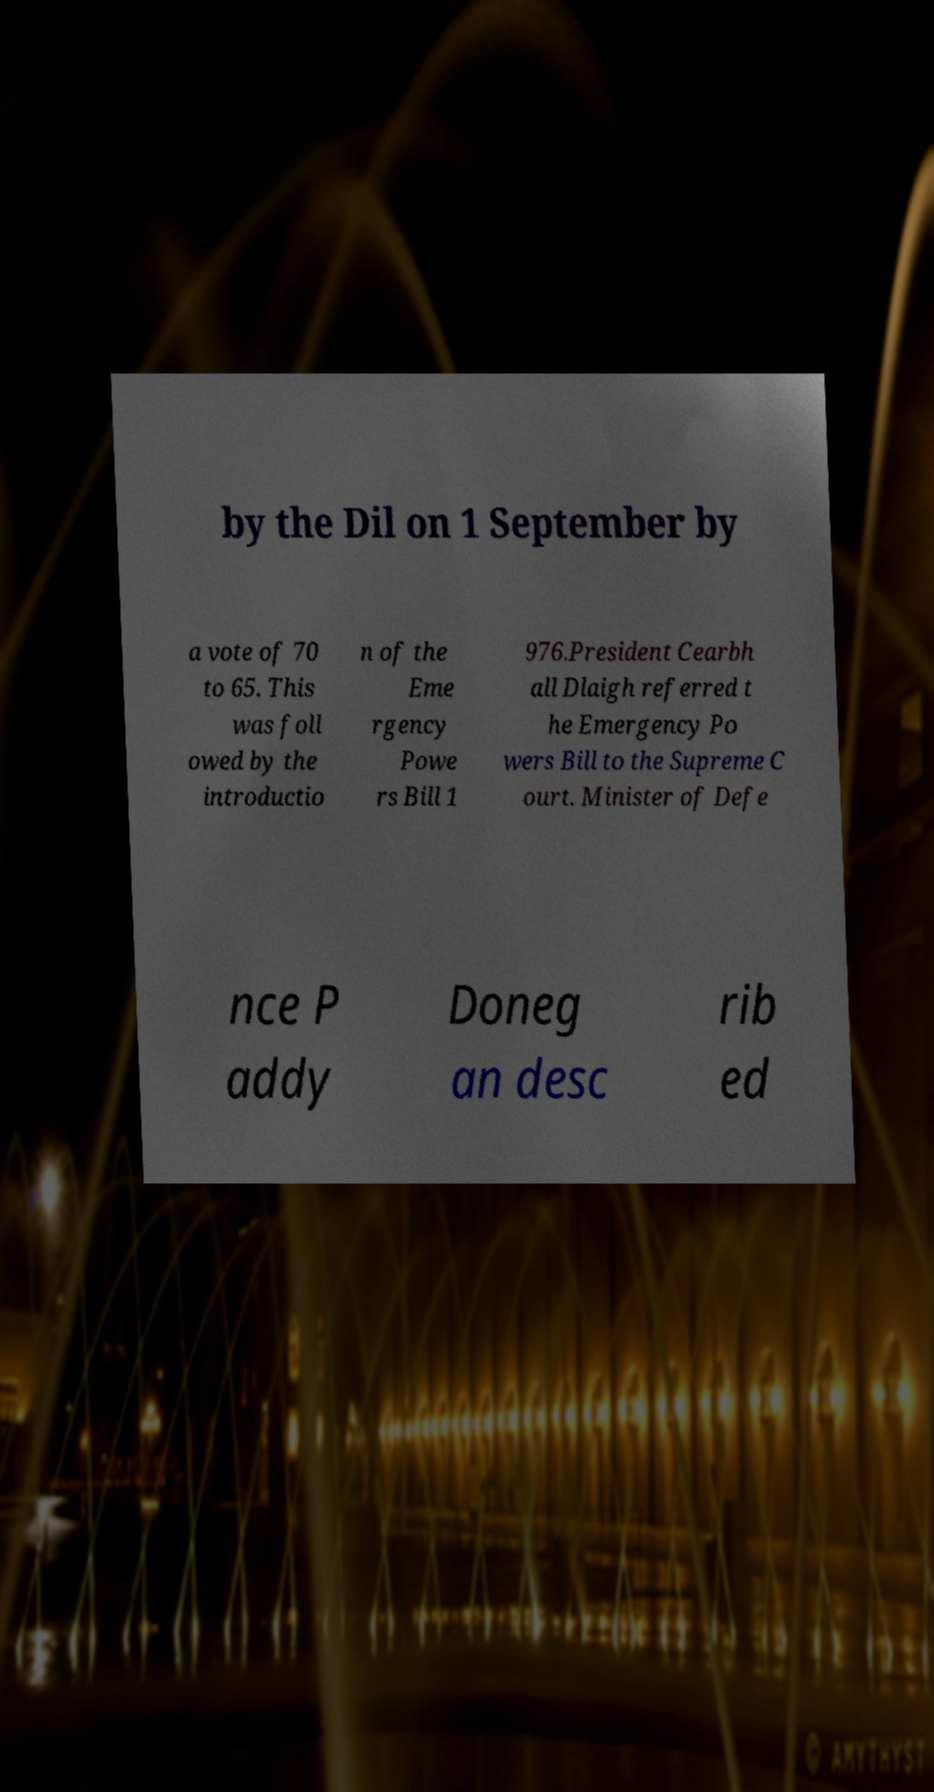There's text embedded in this image that I need extracted. Can you transcribe it verbatim? by the Dil on 1 September by a vote of 70 to 65. This was foll owed by the introductio n of the Eme rgency Powe rs Bill 1 976.President Cearbh all Dlaigh referred t he Emergency Po wers Bill to the Supreme C ourt. Minister of Defe nce P addy Doneg an desc rib ed 